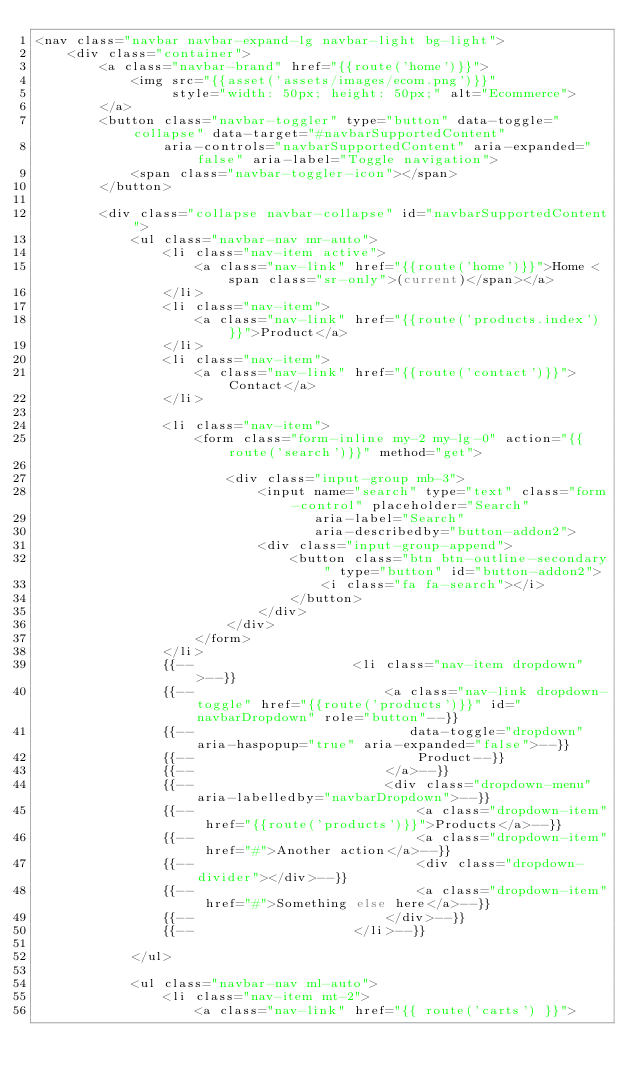<code> <loc_0><loc_0><loc_500><loc_500><_PHP_><nav class="navbar navbar-expand-lg navbar-light bg-light">
    <div class="container">
        <a class="navbar-brand" href="{{route('home')}}">
            <img src="{{asset('assets/images/ecom.png')}}"
                 style="width: 50px; height: 50px;" alt="Ecommerce">
        </a>
        <button class="navbar-toggler" type="button" data-toggle="collapse" data-target="#navbarSupportedContent"
                aria-controls="navbarSupportedContent" aria-expanded="false" aria-label="Toggle navigation">
            <span class="navbar-toggler-icon"></span>
        </button>

        <div class="collapse navbar-collapse" id="navbarSupportedContent">
            <ul class="navbar-nav mr-auto">
                <li class="nav-item active">
                    <a class="nav-link" href="{{route('home')}}">Home <span class="sr-only">(current)</span></a>
                </li>
                <li class="nav-item">
                    <a class="nav-link" href="{{route('products.index')}}">Product</a>
                </li>
                <li class="nav-item">
                    <a class="nav-link" href="{{route('contact')}}">Contact</a>
                </li>

                <li class="nav-item">
                    <form class="form-inline my-2 my-lg-0" action="{{route('search')}}" method="get">

                        <div class="input-group mb-3">
                            <input name="search" type="text" class="form-control" placeholder="Search"
                                   aria-label="Search"
                                   aria-describedby="button-addon2">
                            <div class="input-group-append">
                                <button class="btn btn-outline-secondary" type="button" id="button-addon2">
                                    <i class="fa fa-search"></i>
                                </button>
                            </div>
                        </div>
                    </form>
                </li>
                {{--                    <li class="nav-item dropdown">--}}
                {{--                        <a class="nav-link dropdown-toggle" href="{{route('products')}}" id="navbarDropdown" role="button"--}}
                {{--                           data-toggle="dropdown" aria-haspopup="true" aria-expanded="false">--}}
                {{--                            Product--}}
                {{--                        </a>--}}
                {{--                        <div class="dropdown-menu" aria-labelledby="navbarDropdown">--}}
                {{--                            <a class="dropdown-item" href="{{route('products')}}">Products</a>--}}
                {{--                            <a class="dropdown-item" href="#">Another action</a>--}}
                {{--                            <div class="dropdown-divider"></div>--}}
                {{--                            <a class="dropdown-item" href="#">Something else here</a>--}}
                {{--                        </div>--}}
                {{--                    </li>--}}

            </ul>

            <ul class="navbar-nav ml-auto">
                <li class="nav-item mt-2">
                    <a class="nav-link" href="{{ route('carts') }}"></code> 